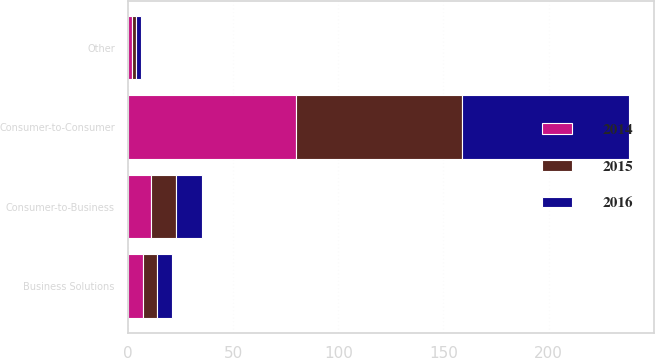Convert chart to OTSL. <chart><loc_0><loc_0><loc_500><loc_500><stacked_bar_chart><ecel><fcel>Consumer-to-Consumer<fcel>Consumer-to-Business<fcel>Business Solutions<fcel>Other<nl><fcel>2016<fcel>79<fcel>12<fcel>7<fcel>2<nl><fcel>2015<fcel>79<fcel>12<fcel>7<fcel>2<nl><fcel>2014<fcel>80<fcel>11<fcel>7<fcel>2<nl></chart> 